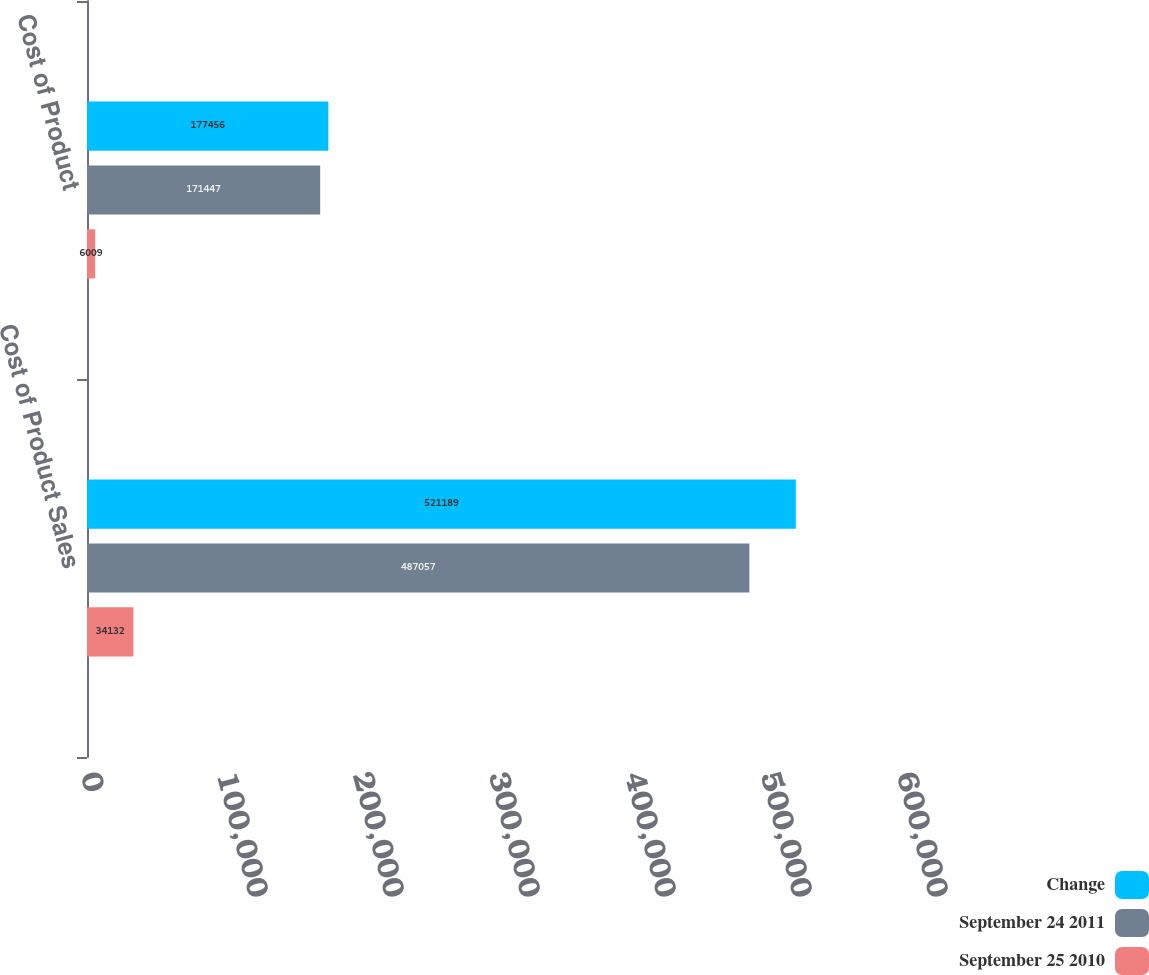Convert chart. <chart><loc_0><loc_0><loc_500><loc_500><stacked_bar_chart><ecel><fcel>Cost of Product Sales<fcel>Cost of Product<nl><fcel>Change<fcel>521189<fcel>177456<nl><fcel>September 24 2011<fcel>487057<fcel>171447<nl><fcel>September 25 2010<fcel>34132<fcel>6009<nl></chart> 